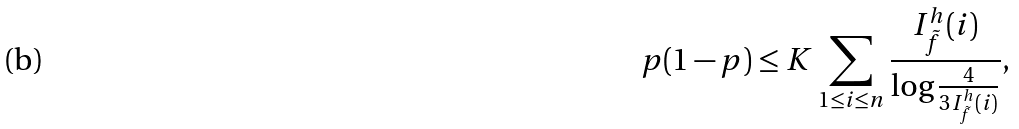Convert formula to latex. <formula><loc_0><loc_0><loc_500><loc_500>p ( 1 - p ) \leq K \sum _ { 1 \leq i \leq n } \frac { I _ { \tilde { f } } ^ { h } ( i ) } { \log \frac { 4 } { 3 I _ { \tilde { f } } ^ { h } ( i ) } } ,</formula> 